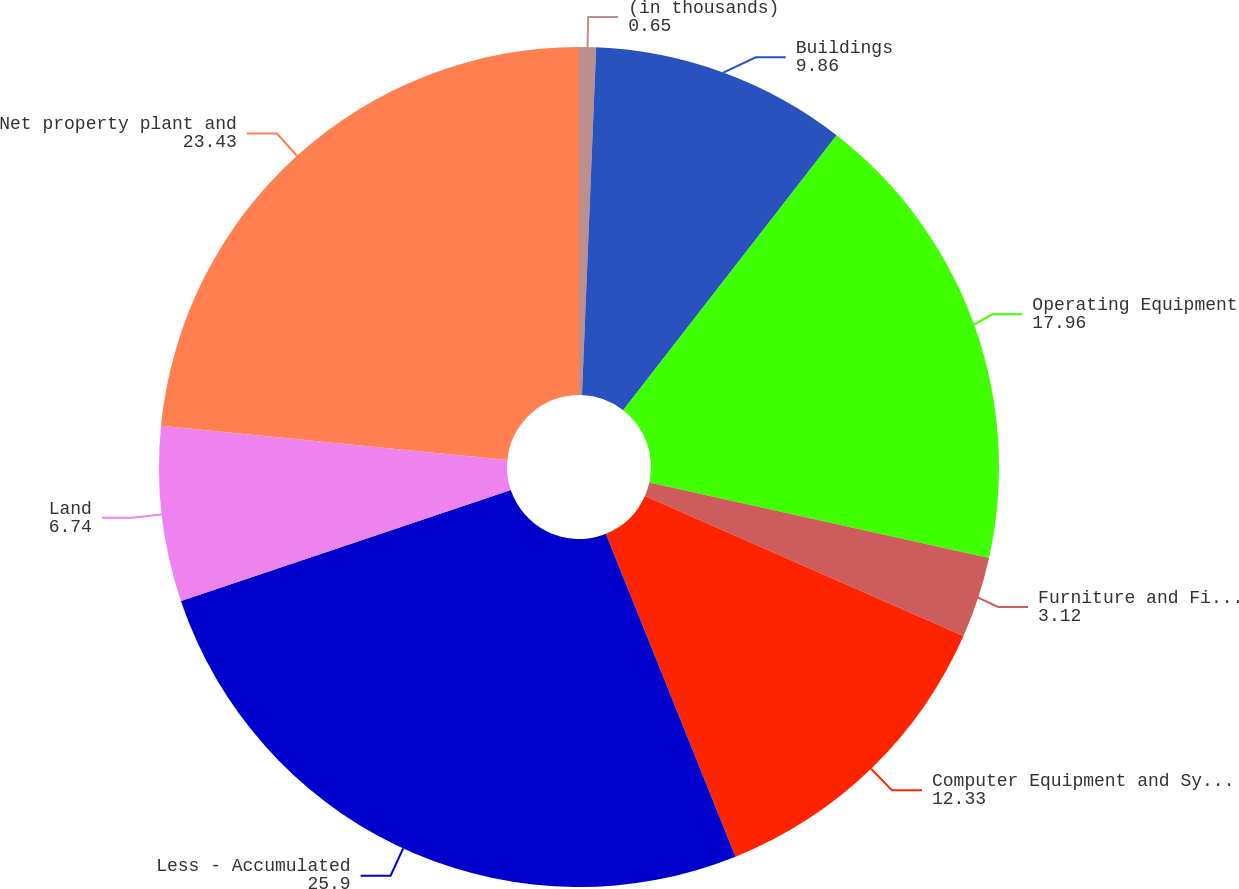Convert chart to OTSL. <chart><loc_0><loc_0><loc_500><loc_500><pie_chart><fcel>(in thousands)<fcel>Buildings<fcel>Operating Equipment<fcel>Furniture and Fixtures<fcel>Computer Equipment and Systems<fcel>Less - Accumulated<fcel>Land<fcel>Net property plant and<nl><fcel>0.65%<fcel>9.86%<fcel>17.96%<fcel>3.12%<fcel>12.33%<fcel>25.9%<fcel>6.74%<fcel>23.43%<nl></chart> 